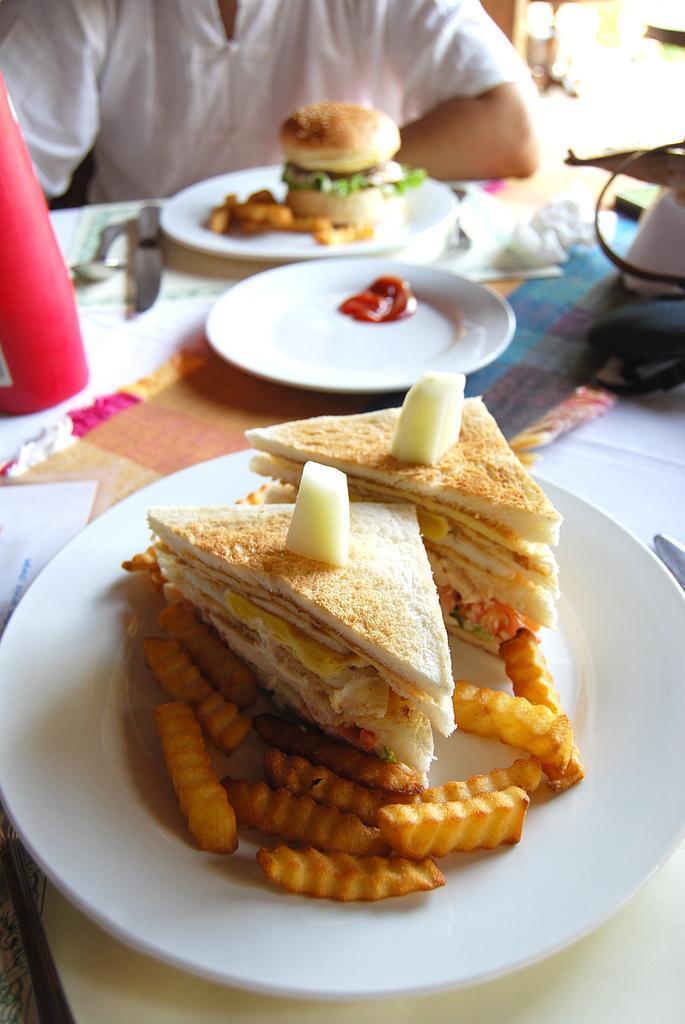How many sandwiches are on the front plate?
Give a very brief answer. 2. How many plates are on the table?
Give a very brief answer. 3. How many pieces of silverware are in front of the person in a white shirt?
Give a very brief answer. 3. How many hamburgers on the picture?
Give a very brief answer. 1. How many sandwiches are on the plate?
Give a very brief answer. 2. 